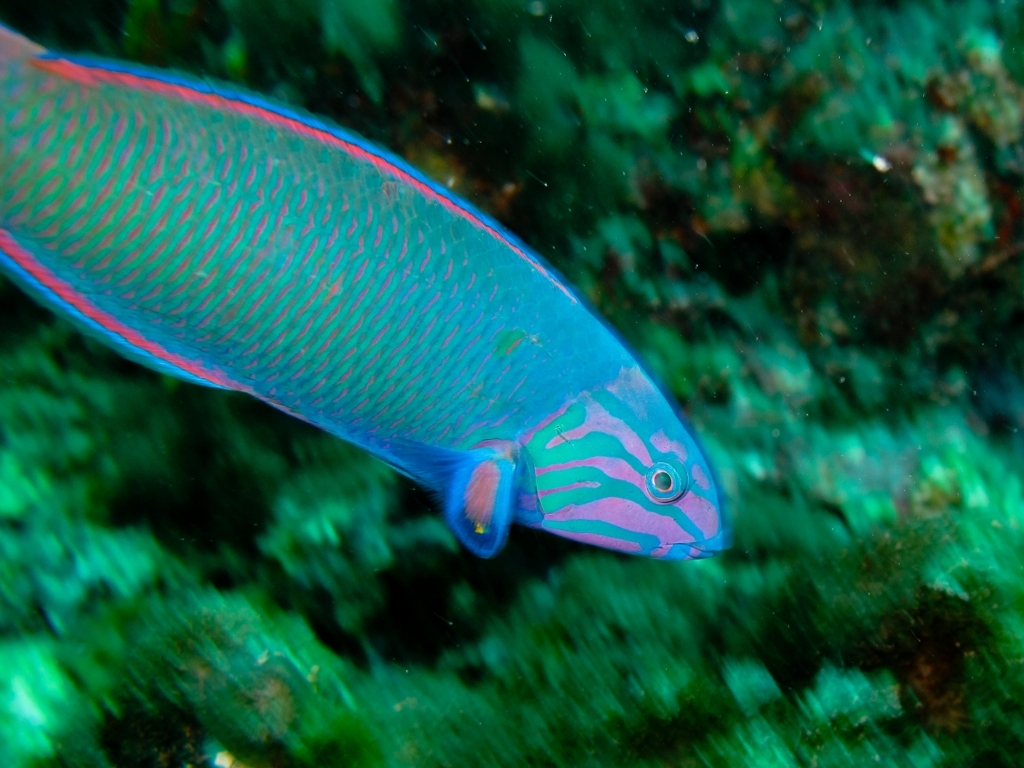Are there minimal details in the background? The background of the image, while not entirely bare, is not cluttered and primarily consists of subdued and relatively uniform aquatic flora that does not draw attention away from the vibrant fish in the foreground. Therefore, it can be said that the background details are minimal but not absent. 